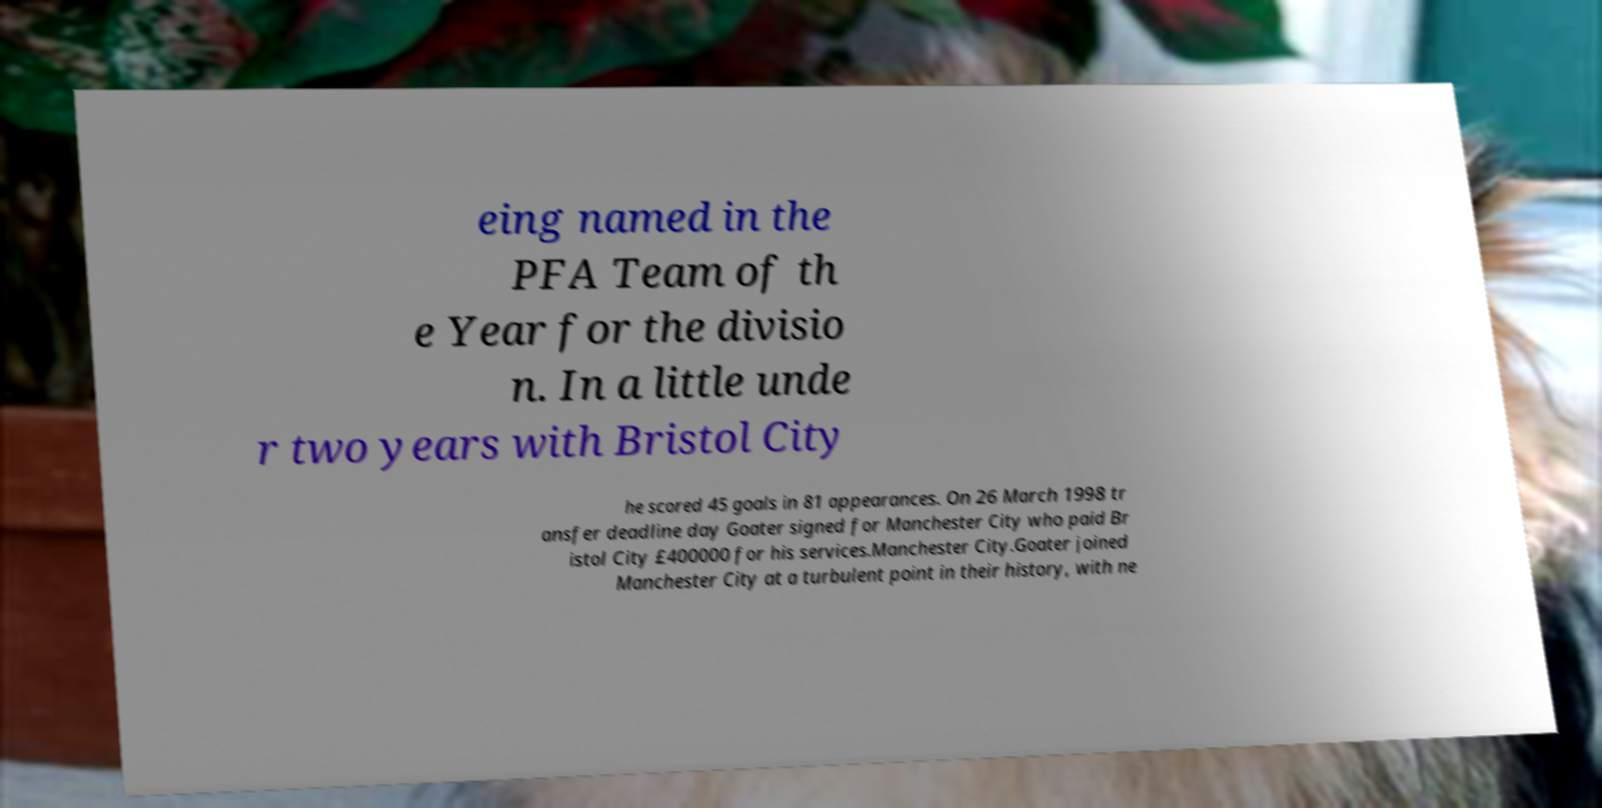Could you assist in decoding the text presented in this image and type it out clearly? eing named in the PFA Team of th e Year for the divisio n. In a little unde r two years with Bristol City he scored 45 goals in 81 appearances. On 26 March 1998 tr ansfer deadline day Goater signed for Manchester City who paid Br istol City £400000 for his services.Manchester City.Goater joined Manchester City at a turbulent point in their history, with ne 